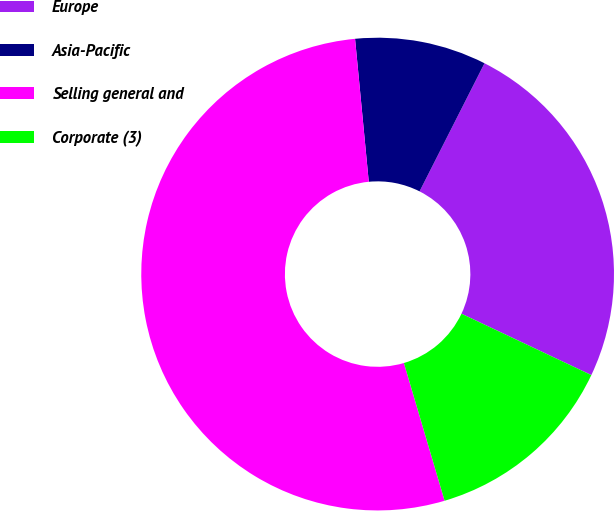Convert chart. <chart><loc_0><loc_0><loc_500><loc_500><pie_chart><fcel>Europe<fcel>Asia-Pacific<fcel>Selling general and<fcel>Corporate (3)<nl><fcel>24.56%<fcel>8.99%<fcel>53.05%<fcel>13.4%<nl></chart> 